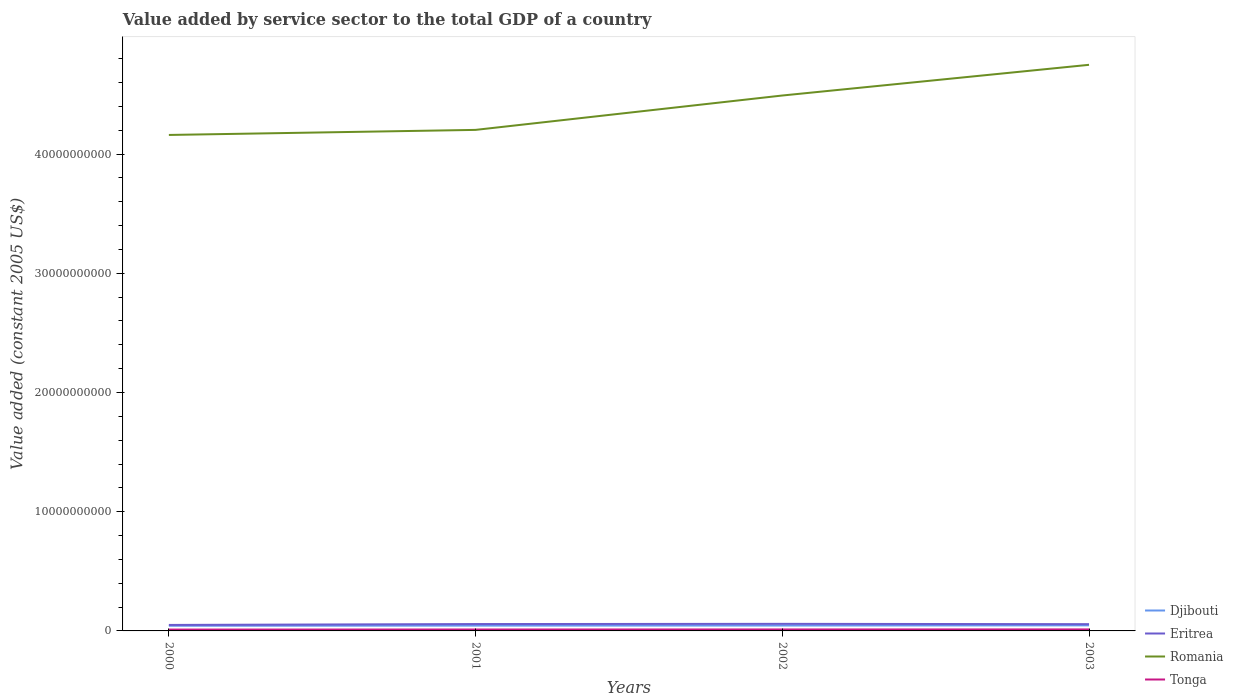Is the number of lines equal to the number of legend labels?
Your answer should be compact. Yes. Across all years, what is the maximum value added by service sector in Romania?
Make the answer very short. 4.16e+1. What is the total value added by service sector in Tonga in the graph?
Offer a very short reply. -4.34e+06. What is the difference between the highest and the second highest value added by service sector in Djibouti?
Offer a very short reply. 3.31e+07. How many lines are there?
Offer a very short reply. 4. How many years are there in the graph?
Your answer should be compact. 4. Does the graph contain grids?
Offer a terse response. No. Where does the legend appear in the graph?
Provide a succinct answer. Bottom right. How many legend labels are there?
Your answer should be very brief. 4. How are the legend labels stacked?
Keep it short and to the point. Vertical. What is the title of the graph?
Give a very brief answer. Value added by service sector to the total GDP of a country. Does "Burkina Faso" appear as one of the legend labels in the graph?
Your answer should be compact. No. What is the label or title of the Y-axis?
Make the answer very short. Value added (constant 2005 US$). What is the Value added (constant 2005 US$) of Djibouti in 2000?
Provide a succinct answer. 4.34e+08. What is the Value added (constant 2005 US$) in Eritrea in 2000?
Your answer should be very brief. 5.01e+08. What is the Value added (constant 2005 US$) in Romania in 2000?
Keep it short and to the point. 4.16e+1. What is the Value added (constant 2005 US$) of Tonga in 2000?
Give a very brief answer. 1.13e+08. What is the Value added (constant 2005 US$) of Djibouti in 2001?
Keep it short and to the point. 4.46e+08. What is the Value added (constant 2005 US$) of Eritrea in 2001?
Your answer should be very brief. 5.76e+08. What is the Value added (constant 2005 US$) in Romania in 2001?
Offer a terse response. 4.20e+1. What is the Value added (constant 2005 US$) of Tonga in 2001?
Offer a very short reply. 1.19e+08. What is the Value added (constant 2005 US$) of Djibouti in 2002?
Give a very brief answer. 4.52e+08. What is the Value added (constant 2005 US$) of Eritrea in 2002?
Keep it short and to the point. 5.93e+08. What is the Value added (constant 2005 US$) in Romania in 2002?
Make the answer very short. 4.49e+1. What is the Value added (constant 2005 US$) of Tonga in 2002?
Your answer should be compact. 1.23e+08. What is the Value added (constant 2005 US$) in Djibouti in 2003?
Give a very brief answer. 4.67e+08. What is the Value added (constant 2005 US$) in Eritrea in 2003?
Provide a succinct answer. 5.67e+08. What is the Value added (constant 2005 US$) of Romania in 2003?
Keep it short and to the point. 4.75e+1. What is the Value added (constant 2005 US$) of Tonga in 2003?
Give a very brief answer. 1.25e+08. Across all years, what is the maximum Value added (constant 2005 US$) in Djibouti?
Provide a short and direct response. 4.67e+08. Across all years, what is the maximum Value added (constant 2005 US$) of Eritrea?
Your response must be concise. 5.93e+08. Across all years, what is the maximum Value added (constant 2005 US$) of Romania?
Provide a short and direct response. 4.75e+1. Across all years, what is the maximum Value added (constant 2005 US$) of Tonga?
Your answer should be compact. 1.25e+08. Across all years, what is the minimum Value added (constant 2005 US$) in Djibouti?
Your answer should be compact. 4.34e+08. Across all years, what is the minimum Value added (constant 2005 US$) of Eritrea?
Offer a very short reply. 5.01e+08. Across all years, what is the minimum Value added (constant 2005 US$) of Romania?
Give a very brief answer. 4.16e+1. Across all years, what is the minimum Value added (constant 2005 US$) of Tonga?
Offer a very short reply. 1.13e+08. What is the total Value added (constant 2005 US$) of Djibouti in the graph?
Your answer should be compact. 1.80e+09. What is the total Value added (constant 2005 US$) of Eritrea in the graph?
Your answer should be compact. 2.24e+09. What is the total Value added (constant 2005 US$) in Romania in the graph?
Your answer should be compact. 1.76e+11. What is the total Value added (constant 2005 US$) in Tonga in the graph?
Offer a very short reply. 4.80e+08. What is the difference between the Value added (constant 2005 US$) of Djibouti in 2000 and that in 2001?
Ensure brevity in your answer.  -1.22e+07. What is the difference between the Value added (constant 2005 US$) in Eritrea in 2000 and that in 2001?
Ensure brevity in your answer.  -7.49e+07. What is the difference between the Value added (constant 2005 US$) of Romania in 2000 and that in 2001?
Keep it short and to the point. -4.25e+08. What is the difference between the Value added (constant 2005 US$) in Tonga in 2000 and that in 2001?
Your answer should be compact. -6.19e+06. What is the difference between the Value added (constant 2005 US$) of Djibouti in 2000 and that in 2002?
Your answer should be very brief. -1.78e+07. What is the difference between the Value added (constant 2005 US$) of Eritrea in 2000 and that in 2002?
Your response must be concise. -9.19e+07. What is the difference between the Value added (constant 2005 US$) in Romania in 2000 and that in 2002?
Ensure brevity in your answer.  -3.31e+09. What is the difference between the Value added (constant 2005 US$) in Tonga in 2000 and that in 2002?
Your answer should be very brief. -1.05e+07. What is the difference between the Value added (constant 2005 US$) in Djibouti in 2000 and that in 2003?
Your response must be concise. -3.31e+07. What is the difference between the Value added (constant 2005 US$) in Eritrea in 2000 and that in 2003?
Give a very brief answer. -6.62e+07. What is the difference between the Value added (constant 2005 US$) in Romania in 2000 and that in 2003?
Provide a short and direct response. -5.88e+09. What is the difference between the Value added (constant 2005 US$) of Tonga in 2000 and that in 2003?
Offer a very short reply. -1.26e+07. What is the difference between the Value added (constant 2005 US$) in Djibouti in 2001 and that in 2002?
Ensure brevity in your answer.  -5.64e+06. What is the difference between the Value added (constant 2005 US$) in Eritrea in 2001 and that in 2002?
Ensure brevity in your answer.  -1.69e+07. What is the difference between the Value added (constant 2005 US$) of Romania in 2001 and that in 2002?
Provide a succinct answer. -2.88e+09. What is the difference between the Value added (constant 2005 US$) of Tonga in 2001 and that in 2002?
Your response must be concise. -4.34e+06. What is the difference between the Value added (constant 2005 US$) in Djibouti in 2001 and that in 2003?
Your response must be concise. -2.09e+07. What is the difference between the Value added (constant 2005 US$) of Eritrea in 2001 and that in 2003?
Offer a very short reply. 8.69e+06. What is the difference between the Value added (constant 2005 US$) of Romania in 2001 and that in 2003?
Your response must be concise. -5.46e+09. What is the difference between the Value added (constant 2005 US$) of Tonga in 2001 and that in 2003?
Your answer should be very brief. -6.44e+06. What is the difference between the Value added (constant 2005 US$) in Djibouti in 2002 and that in 2003?
Your response must be concise. -1.53e+07. What is the difference between the Value added (constant 2005 US$) of Eritrea in 2002 and that in 2003?
Provide a succinct answer. 2.56e+07. What is the difference between the Value added (constant 2005 US$) in Romania in 2002 and that in 2003?
Keep it short and to the point. -2.57e+09. What is the difference between the Value added (constant 2005 US$) in Tonga in 2002 and that in 2003?
Your answer should be compact. -2.10e+06. What is the difference between the Value added (constant 2005 US$) in Djibouti in 2000 and the Value added (constant 2005 US$) in Eritrea in 2001?
Keep it short and to the point. -1.42e+08. What is the difference between the Value added (constant 2005 US$) in Djibouti in 2000 and the Value added (constant 2005 US$) in Romania in 2001?
Your answer should be compact. -4.16e+1. What is the difference between the Value added (constant 2005 US$) of Djibouti in 2000 and the Value added (constant 2005 US$) of Tonga in 2001?
Offer a terse response. 3.15e+08. What is the difference between the Value added (constant 2005 US$) of Eritrea in 2000 and the Value added (constant 2005 US$) of Romania in 2001?
Offer a very short reply. -4.15e+1. What is the difference between the Value added (constant 2005 US$) in Eritrea in 2000 and the Value added (constant 2005 US$) in Tonga in 2001?
Ensure brevity in your answer.  3.82e+08. What is the difference between the Value added (constant 2005 US$) in Romania in 2000 and the Value added (constant 2005 US$) in Tonga in 2001?
Ensure brevity in your answer.  4.15e+1. What is the difference between the Value added (constant 2005 US$) in Djibouti in 2000 and the Value added (constant 2005 US$) in Eritrea in 2002?
Provide a short and direct response. -1.59e+08. What is the difference between the Value added (constant 2005 US$) in Djibouti in 2000 and the Value added (constant 2005 US$) in Romania in 2002?
Offer a very short reply. -4.45e+1. What is the difference between the Value added (constant 2005 US$) of Djibouti in 2000 and the Value added (constant 2005 US$) of Tonga in 2002?
Your answer should be very brief. 3.11e+08. What is the difference between the Value added (constant 2005 US$) of Eritrea in 2000 and the Value added (constant 2005 US$) of Romania in 2002?
Make the answer very short. -4.44e+1. What is the difference between the Value added (constant 2005 US$) of Eritrea in 2000 and the Value added (constant 2005 US$) of Tonga in 2002?
Offer a very short reply. 3.78e+08. What is the difference between the Value added (constant 2005 US$) in Romania in 2000 and the Value added (constant 2005 US$) in Tonga in 2002?
Provide a succinct answer. 4.15e+1. What is the difference between the Value added (constant 2005 US$) of Djibouti in 2000 and the Value added (constant 2005 US$) of Eritrea in 2003?
Your answer should be compact. -1.34e+08. What is the difference between the Value added (constant 2005 US$) of Djibouti in 2000 and the Value added (constant 2005 US$) of Romania in 2003?
Your answer should be very brief. -4.70e+1. What is the difference between the Value added (constant 2005 US$) in Djibouti in 2000 and the Value added (constant 2005 US$) in Tonga in 2003?
Make the answer very short. 3.09e+08. What is the difference between the Value added (constant 2005 US$) of Eritrea in 2000 and the Value added (constant 2005 US$) of Romania in 2003?
Provide a short and direct response. -4.70e+1. What is the difference between the Value added (constant 2005 US$) of Eritrea in 2000 and the Value added (constant 2005 US$) of Tonga in 2003?
Offer a terse response. 3.76e+08. What is the difference between the Value added (constant 2005 US$) of Romania in 2000 and the Value added (constant 2005 US$) of Tonga in 2003?
Give a very brief answer. 4.15e+1. What is the difference between the Value added (constant 2005 US$) of Djibouti in 2001 and the Value added (constant 2005 US$) of Eritrea in 2002?
Provide a short and direct response. -1.47e+08. What is the difference between the Value added (constant 2005 US$) in Djibouti in 2001 and the Value added (constant 2005 US$) in Romania in 2002?
Your response must be concise. -4.45e+1. What is the difference between the Value added (constant 2005 US$) in Djibouti in 2001 and the Value added (constant 2005 US$) in Tonga in 2002?
Keep it short and to the point. 3.23e+08. What is the difference between the Value added (constant 2005 US$) of Eritrea in 2001 and the Value added (constant 2005 US$) of Romania in 2002?
Ensure brevity in your answer.  -4.43e+1. What is the difference between the Value added (constant 2005 US$) of Eritrea in 2001 and the Value added (constant 2005 US$) of Tonga in 2002?
Provide a short and direct response. 4.53e+08. What is the difference between the Value added (constant 2005 US$) of Romania in 2001 and the Value added (constant 2005 US$) of Tonga in 2002?
Offer a very short reply. 4.19e+1. What is the difference between the Value added (constant 2005 US$) of Djibouti in 2001 and the Value added (constant 2005 US$) of Eritrea in 2003?
Provide a short and direct response. -1.22e+08. What is the difference between the Value added (constant 2005 US$) of Djibouti in 2001 and the Value added (constant 2005 US$) of Romania in 2003?
Your answer should be compact. -4.70e+1. What is the difference between the Value added (constant 2005 US$) in Djibouti in 2001 and the Value added (constant 2005 US$) in Tonga in 2003?
Your response must be concise. 3.21e+08. What is the difference between the Value added (constant 2005 US$) in Eritrea in 2001 and the Value added (constant 2005 US$) in Romania in 2003?
Your answer should be compact. -4.69e+1. What is the difference between the Value added (constant 2005 US$) of Eritrea in 2001 and the Value added (constant 2005 US$) of Tonga in 2003?
Provide a short and direct response. 4.51e+08. What is the difference between the Value added (constant 2005 US$) in Romania in 2001 and the Value added (constant 2005 US$) in Tonga in 2003?
Keep it short and to the point. 4.19e+1. What is the difference between the Value added (constant 2005 US$) in Djibouti in 2002 and the Value added (constant 2005 US$) in Eritrea in 2003?
Provide a short and direct response. -1.16e+08. What is the difference between the Value added (constant 2005 US$) of Djibouti in 2002 and the Value added (constant 2005 US$) of Romania in 2003?
Your response must be concise. -4.70e+1. What is the difference between the Value added (constant 2005 US$) in Djibouti in 2002 and the Value added (constant 2005 US$) in Tonga in 2003?
Keep it short and to the point. 3.26e+08. What is the difference between the Value added (constant 2005 US$) in Eritrea in 2002 and the Value added (constant 2005 US$) in Romania in 2003?
Offer a very short reply. -4.69e+1. What is the difference between the Value added (constant 2005 US$) in Eritrea in 2002 and the Value added (constant 2005 US$) in Tonga in 2003?
Your answer should be very brief. 4.68e+08. What is the difference between the Value added (constant 2005 US$) of Romania in 2002 and the Value added (constant 2005 US$) of Tonga in 2003?
Your answer should be very brief. 4.48e+1. What is the average Value added (constant 2005 US$) of Djibouti per year?
Your answer should be very brief. 4.50e+08. What is the average Value added (constant 2005 US$) in Eritrea per year?
Offer a terse response. 5.60e+08. What is the average Value added (constant 2005 US$) in Romania per year?
Give a very brief answer. 4.40e+1. What is the average Value added (constant 2005 US$) in Tonga per year?
Provide a short and direct response. 1.20e+08. In the year 2000, what is the difference between the Value added (constant 2005 US$) in Djibouti and Value added (constant 2005 US$) in Eritrea?
Your answer should be compact. -6.75e+07. In the year 2000, what is the difference between the Value added (constant 2005 US$) of Djibouti and Value added (constant 2005 US$) of Romania?
Provide a short and direct response. -4.12e+1. In the year 2000, what is the difference between the Value added (constant 2005 US$) of Djibouti and Value added (constant 2005 US$) of Tonga?
Keep it short and to the point. 3.21e+08. In the year 2000, what is the difference between the Value added (constant 2005 US$) of Eritrea and Value added (constant 2005 US$) of Romania?
Provide a short and direct response. -4.11e+1. In the year 2000, what is the difference between the Value added (constant 2005 US$) in Eritrea and Value added (constant 2005 US$) in Tonga?
Offer a terse response. 3.89e+08. In the year 2000, what is the difference between the Value added (constant 2005 US$) of Romania and Value added (constant 2005 US$) of Tonga?
Keep it short and to the point. 4.15e+1. In the year 2001, what is the difference between the Value added (constant 2005 US$) of Djibouti and Value added (constant 2005 US$) of Eritrea?
Offer a very short reply. -1.30e+08. In the year 2001, what is the difference between the Value added (constant 2005 US$) in Djibouti and Value added (constant 2005 US$) in Romania?
Give a very brief answer. -4.16e+1. In the year 2001, what is the difference between the Value added (constant 2005 US$) of Djibouti and Value added (constant 2005 US$) of Tonga?
Provide a succinct answer. 3.27e+08. In the year 2001, what is the difference between the Value added (constant 2005 US$) of Eritrea and Value added (constant 2005 US$) of Romania?
Offer a very short reply. -4.14e+1. In the year 2001, what is the difference between the Value added (constant 2005 US$) of Eritrea and Value added (constant 2005 US$) of Tonga?
Your response must be concise. 4.57e+08. In the year 2001, what is the difference between the Value added (constant 2005 US$) of Romania and Value added (constant 2005 US$) of Tonga?
Ensure brevity in your answer.  4.19e+1. In the year 2002, what is the difference between the Value added (constant 2005 US$) of Djibouti and Value added (constant 2005 US$) of Eritrea?
Keep it short and to the point. -1.42e+08. In the year 2002, what is the difference between the Value added (constant 2005 US$) in Djibouti and Value added (constant 2005 US$) in Romania?
Offer a terse response. -4.45e+1. In the year 2002, what is the difference between the Value added (constant 2005 US$) of Djibouti and Value added (constant 2005 US$) of Tonga?
Keep it short and to the point. 3.28e+08. In the year 2002, what is the difference between the Value added (constant 2005 US$) of Eritrea and Value added (constant 2005 US$) of Romania?
Provide a succinct answer. -4.43e+1. In the year 2002, what is the difference between the Value added (constant 2005 US$) of Eritrea and Value added (constant 2005 US$) of Tonga?
Provide a short and direct response. 4.70e+08. In the year 2002, what is the difference between the Value added (constant 2005 US$) in Romania and Value added (constant 2005 US$) in Tonga?
Your answer should be very brief. 4.48e+1. In the year 2003, what is the difference between the Value added (constant 2005 US$) of Djibouti and Value added (constant 2005 US$) of Eritrea?
Ensure brevity in your answer.  -1.01e+08. In the year 2003, what is the difference between the Value added (constant 2005 US$) in Djibouti and Value added (constant 2005 US$) in Romania?
Your answer should be compact. -4.70e+1. In the year 2003, what is the difference between the Value added (constant 2005 US$) in Djibouti and Value added (constant 2005 US$) in Tonga?
Make the answer very short. 3.42e+08. In the year 2003, what is the difference between the Value added (constant 2005 US$) in Eritrea and Value added (constant 2005 US$) in Romania?
Offer a terse response. -4.69e+1. In the year 2003, what is the difference between the Value added (constant 2005 US$) of Eritrea and Value added (constant 2005 US$) of Tonga?
Offer a very short reply. 4.42e+08. In the year 2003, what is the difference between the Value added (constant 2005 US$) of Romania and Value added (constant 2005 US$) of Tonga?
Your response must be concise. 4.74e+1. What is the ratio of the Value added (constant 2005 US$) in Djibouti in 2000 to that in 2001?
Your response must be concise. 0.97. What is the ratio of the Value added (constant 2005 US$) in Eritrea in 2000 to that in 2001?
Offer a very short reply. 0.87. What is the ratio of the Value added (constant 2005 US$) in Tonga in 2000 to that in 2001?
Provide a short and direct response. 0.95. What is the ratio of the Value added (constant 2005 US$) in Djibouti in 2000 to that in 2002?
Your response must be concise. 0.96. What is the ratio of the Value added (constant 2005 US$) of Eritrea in 2000 to that in 2002?
Provide a succinct answer. 0.85. What is the ratio of the Value added (constant 2005 US$) in Romania in 2000 to that in 2002?
Make the answer very short. 0.93. What is the ratio of the Value added (constant 2005 US$) in Tonga in 2000 to that in 2002?
Your answer should be very brief. 0.91. What is the ratio of the Value added (constant 2005 US$) in Djibouti in 2000 to that in 2003?
Offer a terse response. 0.93. What is the ratio of the Value added (constant 2005 US$) in Eritrea in 2000 to that in 2003?
Offer a terse response. 0.88. What is the ratio of the Value added (constant 2005 US$) of Romania in 2000 to that in 2003?
Your response must be concise. 0.88. What is the ratio of the Value added (constant 2005 US$) in Tonga in 2000 to that in 2003?
Offer a very short reply. 0.9. What is the ratio of the Value added (constant 2005 US$) of Djibouti in 2001 to that in 2002?
Provide a short and direct response. 0.99. What is the ratio of the Value added (constant 2005 US$) of Eritrea in 2001 to that in 2002?
Your answer should be compact. 0.97. What is the ratio of the Value added (constant 2005 US$) of Romania in 2001 to that in 2002?
Ensure brevity in your answer.  0.94. What is the ratio of the Value added (constant 2005 US$) of Tonga in 2001 to that in 2002?
Give a very brief answer. 0.96. What is the ratio of the Value added (constant 2005 US$) of Djibouti in 2001 to that in 2003?
Your response must be concise. 0.96. What is the ratio of the Value added (constant 2005 US$) in Eritrea in 2001 to that in 2003?
Your response must be concise. 1.02. What is the ratio of the Value added (constant 2005 US$) in Romania in 2001 to that in 2003?
Your answer should be very brief. 0.89. What is the ratio of the Value added (constant 2005 US$) of Tonga in 2001 to that in 2003?
Make the answer very short. 0.95. What is the ratio of the Value added (constant 2005 US$) of Djibouti in 2002 to that in 2003?
Your answer should be very brief. 0.97. What is the ratio of the Value added (constant 2005 US$) in Eritrea in 2002 to that in 2003?
Your answer should be very brief. 1.05. What is the ratio of the Value added (constant 2005 US$) in Romania in 2002 to that in 2003?
Ensure brevity in your answer.  0.95. What is the ratio of the Value added (constant 2005 US$) in Tonga in 2002 to that in 2003?
Provide a succinct answer. 0.98. What is the difference between the highest and the second highest Value added (constant 2005 US$) in Djibouti?
Provide a short and direct response. 1.53e+07. What is the difference between the highest and the second highest Value added (constant 2005 US$) of Eritrea?
Make the answer very short. 1.69e+07. What is the difference between the highest and the second highest Value added (constant 2005 US$) of Romania?
Offer a terse response. 2.57e+09. What is the difference between the highest and the second highest Value added (constant 2005 US$) of Tonga?
Your answer should be compact. 2.10e+06. What is the difference between the highest and the lowest Value added (constant 2005 US$) in Djibouti?
Offer a terse response. 3.31e+07. What is the difference between the highest and the lowest Value added (constant 2005 US$) of Eritrea?
Offer a very short reply. 9.19e+07. What is the difference between the highest and the lowest Value added (constant 2005 US$) in Romania?
Provide a short and direct response. 5.88e+09. What is the difference between the highest and the lowest Value added (constant 2005 US$) in Tonga?
Ensure brevity in your answer.  1.26e+07. 